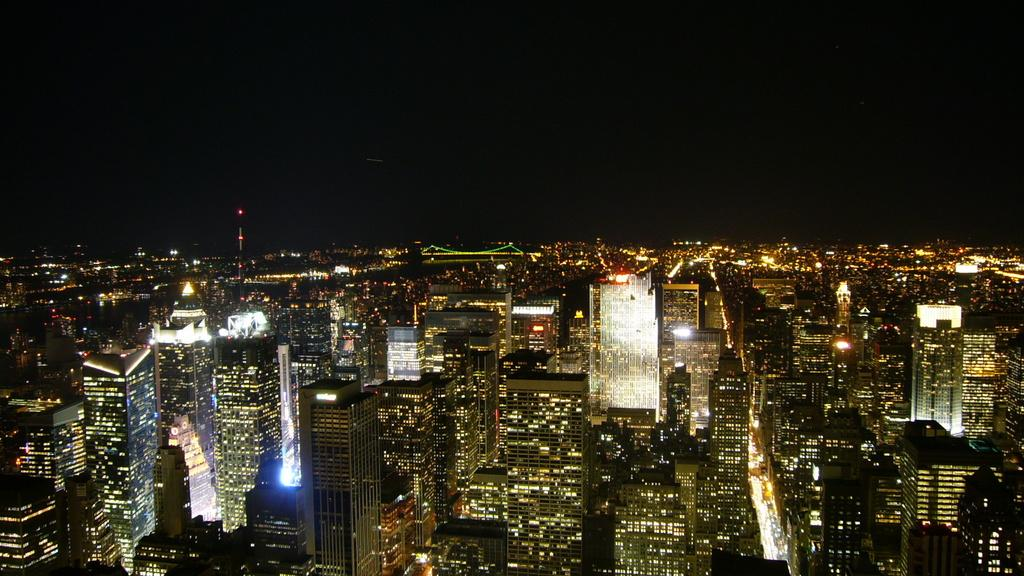What type of structures can be seen in the image? There are many buildings, a bridge, and towers in the image. What natural phenomenon is present in the image? Lightnings are present in the image. What type of transportation is visible in the image? Vehicles are visible in the image. What part of the natural environment is visible in the image? The sky is visible at the top of the image. Where is the tray of food located in the image? There is no tray of food present in the image. How many sheep can be seen grazing in the image? There are no sheep present in the image. 